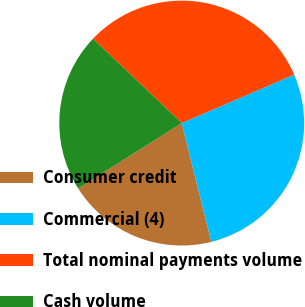<chart> <loc_0><loc_0><loc_500><loc_500><pie_chart><fcel>Consumer credit<fcel>Commercial (4)<fcel>Total nominal payments volume<fcel>Cash volume<nl><fcel>19.92%<fcel>27.59%<fcel>31.42%<fcel>21.07%<nl></chart> 